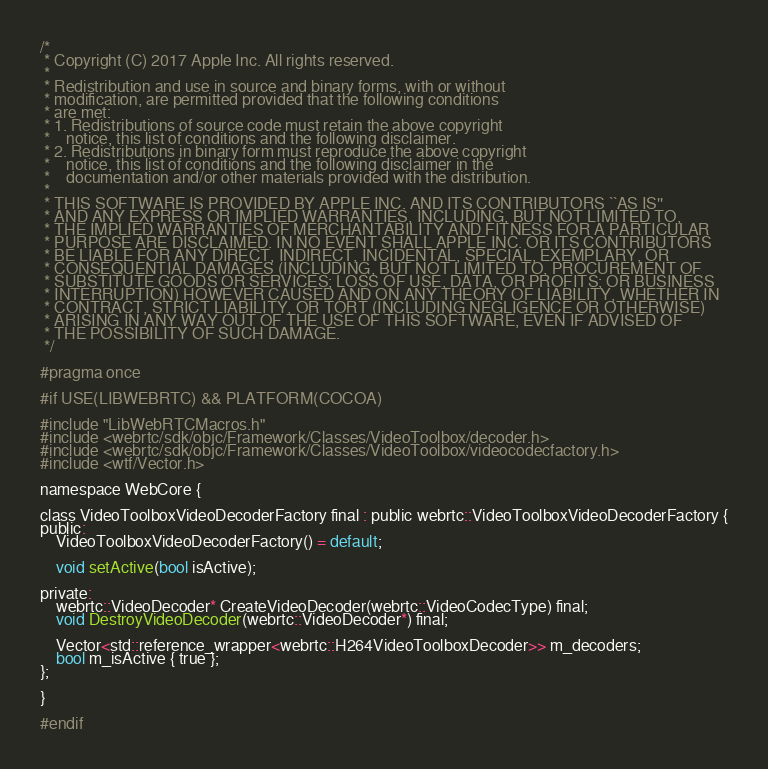Convert code to text. <code><loc_0><loc_0><loc_500><loc_500><_C_>/*
 * Copyright (C) 2017 Apple Inc. All rights reserved.
 *
 * Redistribution and use in source and binary forms, with or without
 * modification, are permitted provided that the following conditions
 * are met:
 * 1. Redistributions of source code must retain the above copyright
 *    notice, this list of conditions and the following disclaimer.
 * 2. Redistributions in binary form must reproduce the above copyright
 *    notice, this list of conditions and the following disclaimer in the
 *    documentation and/or other materials provided with the distribution.
 *
 * THIS SOFTWARE IS PROVIDED BY APPLE INC. AND ITS CONTRIBUTORS ``AS IS''
 * AND ANY EXPRESS OR IMPLIED WARRANTIES, INCLUDING, BUT NOT LIMITED TO,
 * THE IMPLIED WARRANTIES OF MERCHANTABILITY AND FITNESS FOR A PARTICULAR
 * PURPOSE ARE DISCLAIMED. IN NO EVENT SHALL APPLE INC. OR ITS CONTRIBUTORS
 * BE LIABLE FOR ANY DIRECT, INDIRECT, INCIDENTAL, SPECIAL, EXEMPLARY, OR
 * CONSEQUENTIAL DAMAGES (INCLUDING, BUT NOT LIMITED TO, PROCUREMENT OF
 * SUBSTITUTE GOODS OR SERVICES; LOSS OF USE, DATA, OR PROFITS; OR BUSINESS
 * INTERRUPTION) HOWEVER CAUSED AND ON ANY THEORY OF LIABILITY, WHETHER IN
 * CONTRACT, STRICT LIABILITY, OR TORT (INCLUDING NEGLIGENCE OR OTHERWISE)
 * ARISING IN ANY WAY OUT OF THE USE OF THIS SOFTWARE, EVEN IF ADVISED OF
 * THE POSSIBILITY OF SUCH DAMAGE.
 */

#pragma once

#if USE(LIBWEBRTC) && PLATFORM(COCOA)

#include "LibWebRTCMacros.h"
#include <webrtc/sdk/objc/Framework/Classes/VideoToolbox/decoder.h>
#include <webrtc/sdk/objc/Framework/Classes/VideoToolbox/videocodecfactory.h>
#include <wtf/Vector.h>

namespace WebCore {

class VideoToolboxVideoDecoderFactory final : public webrtc::VideoToolboxVideoDecoderFactory {
public:
    VideoToolboxVideoDecoderFactory() = default;

    void setActive(bool isActive);

private:
    webrtc::VideoDecoder* CreateVideoDecoder(webrtc::VideoCodecType) final;
    void DestroyVideoDecoder(webrtc::VideoDecoder*) final;

    Vector<std::reference_wrapper<webrtc::H264VideoToolboxDecoder>> m_decoders;
    bool m_isActive { true };
};

}

#endif
</code> 